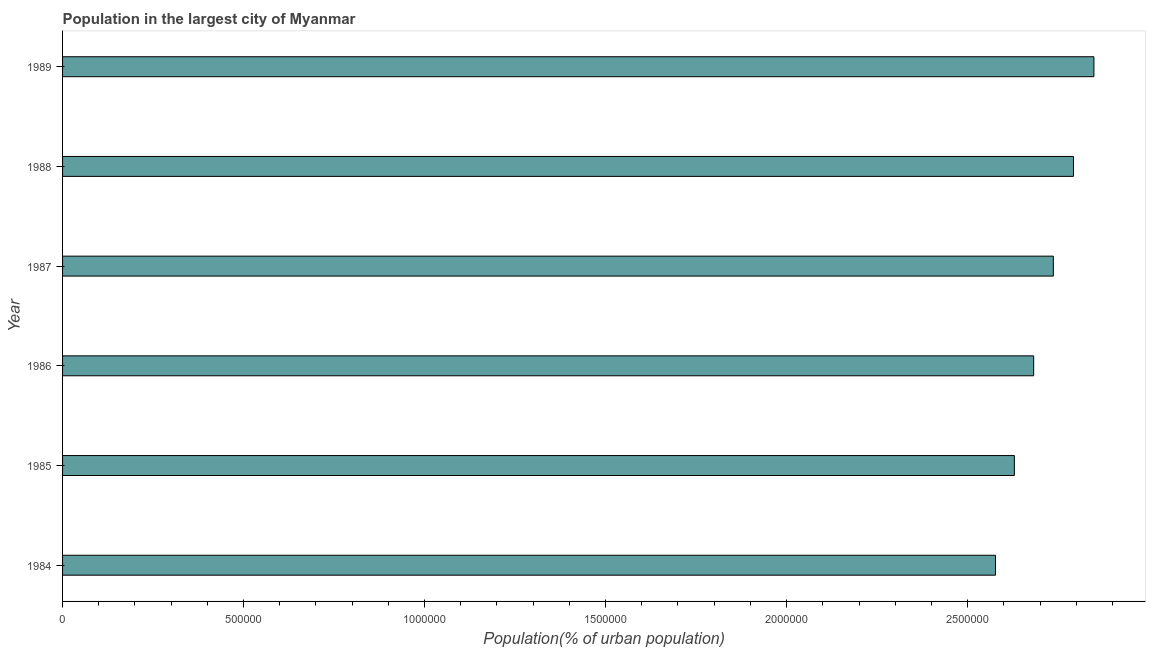Does the graph contain any zero values?
Your answer should be very brief. No. What is the title of the graph?
Your answer should be very brief. Population in the largest city of Myanmar. What is the label or title of the X-axis?
Provide a short and direct response. Population(% of urban population). What is the label or title of the Y-axis?
Ensure brevity in your answer.  Year. What is the population in largest city in 1989?
Provide a short and direct response. 2.85e+06. Across all years, what is the maximum population in largest city?
Give a very brief answer. 2.85e+06. Across all years, what is the minimum population in largest city?
Provide a succinct answer. 2.58e+06. In which year was the population in largest city maximum?
Offer a terse response. 1989. What is the sum of the population in largest city?
Offer a terse response. 1.63e+07. What is the difference between the population in largest city in 1986 and 1987?
Your answer should be compact. -5.44e+04. What is the average population in largest city per year?
Make the answer very short. 2.71e+06. What is the median population in largest city?
Provide a short and direct response. 2.71e+06. In how many years, is the population in largest city greater than 1600000 %?
Offer a terse response. 6. Do a majority of the years between 1987 and 1984 (inclusive) have population in largest city greater than 500000 %?
Your response must be concise. Yes. What is the ratio of the population in largest city in 1984 to that in 1988?
Your answer should be very brief. 0.92. What is the difference between the highest and the second highest population in largest city?
Make the answer very short. 5.65e+04. What is the difference between the highest and the lowest population in largest city?
Your answer should be compact. 2.72e+05. In how many years, is the population in largest city greater than the average population in largest city taken over all years?
Give a very brief answer. 3. What is the difference between two consecutive major ticks on the X-axis?
Your response must be concise. 5.00e+05. What is the Population(% of urban population) of 1984?
Your answer should be very brief. 2.58e+06. What is the Population(% of urban population) of 1985?
Make the answer very short. 2.63e+06. What is the Population(% of urban population) in 1986?
Make the answer very short. 2.68e+06. What is the Population(% of urban population) of 1987?
Your response must be concise. 2.74e+06. What is the Population(% of urban population) of 1988?
Your answer should be compact. 2.79e+06. What is the Population(% of urban population) in 1989?
Offer a terse response. 2.85e+06. What is the difference between the Population(% of urban population) in 1984 and 1985?
Your response must be concise. -5.22e+04. What is the difference between the Population(% of urban population) in 1984 and 1986?
Make the answer very short. -1.05e+05. What is the difference between the Population(% of urban population) in 1984 and 1987?
Your answer should be compact. -1.60e+05. What is the difference between the Population(% of urban population) in 1984 and 1988?
Provide a succinct answer. -2.15e+05. What is the difference between the Population(% of urban population) in 1984 and 1989?
Provide a succinct answer. -2.72e+05. What is the difference between the Population(% of urban population) in 1985 and 1986?
Your answer should be compact. -5.33e+04. What is the difference between the Population(% of urban population) in 1985 and 1987?
Make the answer very short. -1.08e+05. What is the difference between the Population(% of urban population) in 1985 and 1988?
Provide a succinct answer. -1.63e+05. What is the difference between the Population(% of urban population) in 1985 and 1989?
Your answer should be very brief. -2.20e+05. What is the difference between the Population(% of urban population) in 1986 and 1987?
Give a very brief answer. -5.44e+04. What is the difference between the Population(% of urban population) in 1986 and 1988?
Keep it short and to the point. -1.10e+05. What is the difference between the Population(% of urban population) in 1986 and 1989?
Provide a succinct answer. -1.66e+05. What is the difference between the Population(% of urban population) in 1987 and 1988?
Ensure brevity in your answer.  -5.56e+04. What is the difference between the Population(% of urban population) in 1987 and 1989?
Make the answer very short. -1.12e+05. What is the difference between the Population(% of urban population) in 1988 and 1989?
Keep it short and to the point. -5.65e+04. What is the ratio of the Population(% of urban population) in 1984 to that in 1986?
Offer a very short reply. 0.96. What is the ratio of the Population(% of urban population) in 1984 to that in 1987?
Keep it short and to the point. 0.94. What is the ratio of the Population(% of urban population) in 1984 to that in 1988?
Keep it short and to the point. 0.92. What is the ratio of the Population(% of urban population) in 1984 to that in 1989?
Make the answer very short. 0.91. What is the ratio of the Population(% of urban population) in 1985 to that in 1986?
Offer a terse response. 0.98. What is the ratio of the Population(% of urban population) in 1985 to that in 1988?
Offer a terse response. 0.94. What is the ratio of the Population(% of urban population) in 1985 to that in 1989?
Provide a succinct answer. 0.92. What is the ratio of the Population(% of urban population) in 1986 to that in 1989?
Your answer should be very brief. 0.94. What is the ratio of the Population(% of urban population) in 1988 to that in 1989?
Make the answer very short. 0.98. 